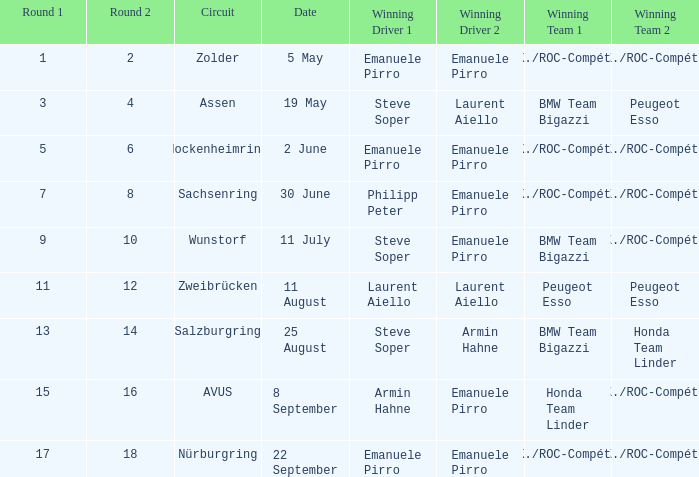Which driver secured the win in the race that took place on may 5? Emanuele Pirro Emanuele Pirro. 